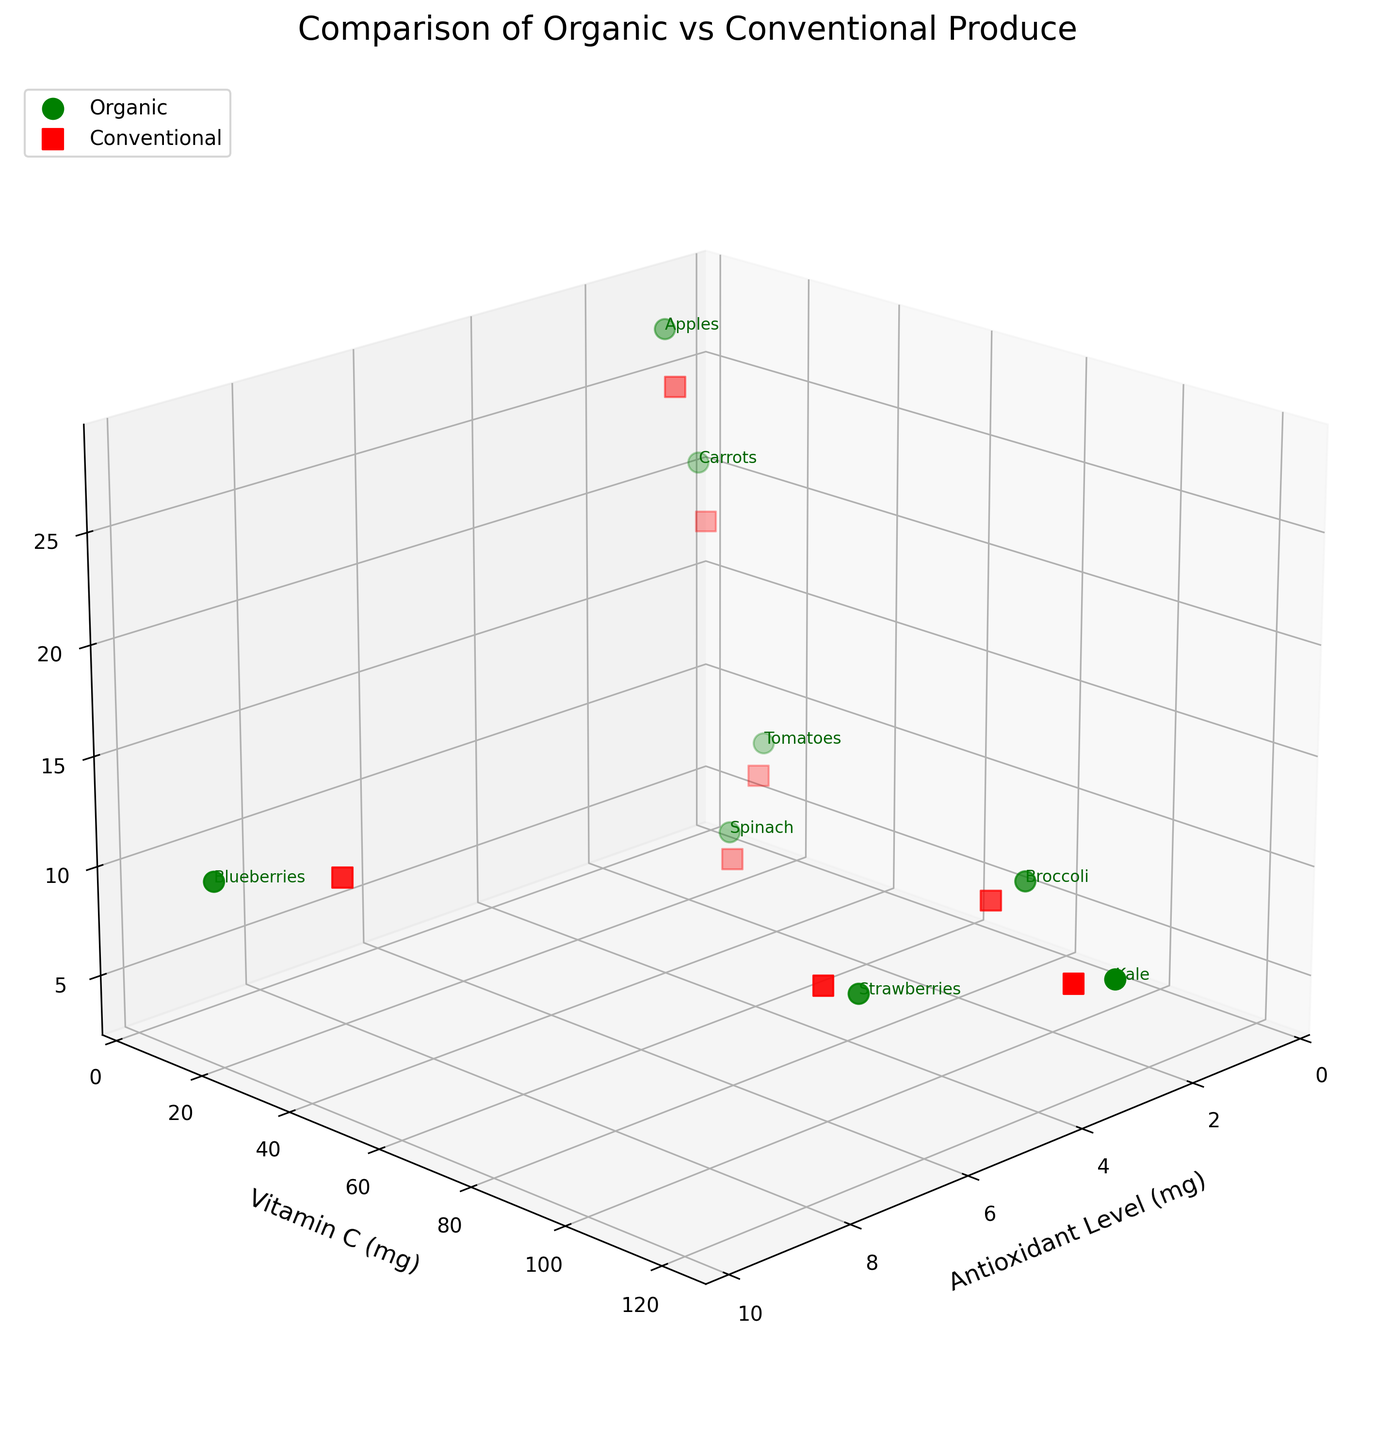What is the color used to represent organic produce in the figure? Organic produce is represented by the color green, as indicated in the legend that explains the color-coding for organic and conventional produce.
Answer: Green Which type of produce has the highest antioxidant level? The highest antioxidant level can be identified from the plot by looking at the leftmost data point on the X-axis (Antioxidant Level). Organic Blueberries are positioned at this point with an antioxidant level of 9.7 mg.
Answer: Organic Blueberries How does the vitamin C content of organic kale compare to conventional kale? By locating the data points for both types of kale (organic and conventional) in the Y-axis (Vitamin C), organic kale has a higher vitamin C content (120.5 mg) than conventional kale (105.3 mg).
Answer: Organic kale has higher vitamin C content Which type of produce has the longest shelf life? The longest shelf life can be identified by looking at the data points furthest along the Z-axis (Shelf Life). Organic Apples are positioned at this point with a shelf life of 28 days.
Answer: Organic Apples What is the difference in antioxidant levels between organic and conventional strawberries? Firstly, find the antioxidant levels of both organic (4.2 mg) and conventional strawberries (3.8 mg). The difference is calculated as 4.2 mg - 3.8 mg = 0.4 mg.
Answer: 0.4 mg Which has a higher overall vitamin C content, organic or conventional produce? To determine this, consider the individual vitamin C content values for organic and conventional produce, respectively. Summing up the Vitamin C values for organic gives: 14.2 + 120.5 + 5.9 + 84.7 + 28.1 + 23.4 + 8.4 + 89.2 = 374.4 mg. For conventional: 12.8 + 105.3 + 5.1 + 72.3 + 23.7 + 19.8 + 6.9 + 78.5 = 324.4 mg. Thus, organic produce has a higher overall vitamin C content.
Answer: Organic produce has higher vitamin C Among the types of produce shown, which exhibit a longer shelf life when organic compared to conventional? By comparing the shelf life values on the Z-axis for each produce type, Organic Blueberries (10 vs 8 days), Organic Kale (7 vs 5 days), Organic Carrots (21 vs 18 days), Organic Strawberries (5 vs 4 days), Organic Spinach (6 vs 4 days), Organic Tomatoes (9 vs 7 days), Organic Apples (28 vs 25 days), and Organic Broccoli (8 vs 6 days) all exhibit longer shelf life compared to their conventional counterparts.
Answer: All shown types What is the average shelf life of organic vegetables (excluding fruits)? Organic vegetables include Kale, Carrots, Spinach, and Broccoli. Their shelf life values are 7, 21, 6, and 8 days, respectively. The average is calculated as (7 + 21 + 6 + 8) / 4 = 42 / 4 = 10.5 days.
Answer: 10.5 days 